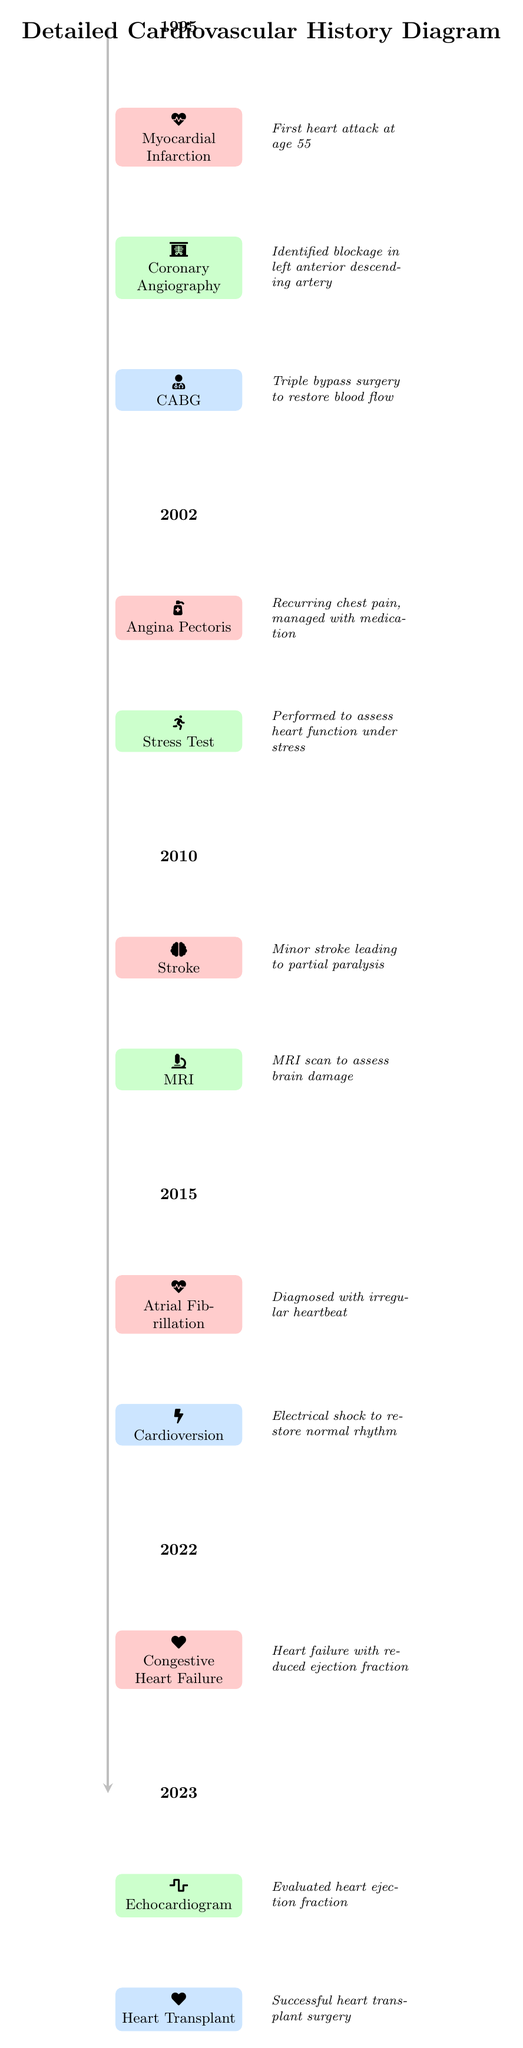What year did the first myocardial infarction occur? The diagram indicates that the first myocardial infarction took place in 1995, as noted in the timeline at that year.
Answer: 1995 What intervention was performed after the coronary angiography? Following the coronary angiography in 1995, the next intervention noted is CABG (Coronary Artery Bypass Grafting) which occurred due to the identified blockage.
Answer: CABG How many tests are listed in the diagram? The diagram lists a total of four tests: Coronary Angiography, Stress Test, MRI, and Echocardiogram. By counting each test mentioned in the diagram, the total is calculated.
Answer: 4 What medical condition was diagnosed in 2015? In 2015, the diagram indicates that the patient was diagnosed with atrial fibrillation, which is a condition characterized by an irregular heartbeat. This is found in the respective year entry.
Answer: Atrial Fibrillation What event occurred immediately after the stroke in 2010? The diagram shows that immediately after the stroke event in 2010, an MRI test was performed in the following timeline step to assess the brain damage, illustrating the sequence.
Answer: MRI What year was the heart transplant performed? The heart transplant is recorded as taking place in 2023, as indicated by the year node directly preceding it in the timeline.
Answer: 2023 What symptoms were managed with medication in 2002? The 2002 entry highlights that angina pectoris was managed with medication, clarifying the symptoms experienced during that time period.
Answer: Angina Pectoris What was the result of the stress test performed in 2002? The stress test, which was performed after the diagnosis of angina pectoris in 2002, aimed at assessing heart function under stress, suggesting a monitoring of cardiovascular capacity.
Answer: Assess heart function What type of surgery is indicated in the diagram? The type of surgery indicated in the diagram is a heart transplant, which is explicitly labeled in the event node in 2023.
Answer: Heart Transplant 